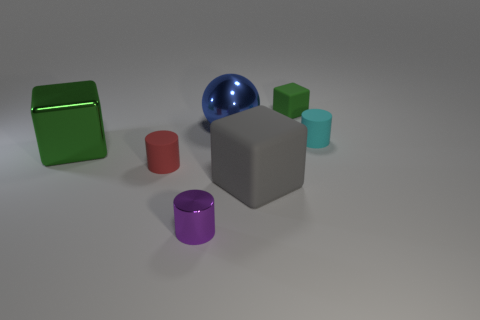Subtract all tiny matte cylinders. How many cylinders are left? 1 Subtract all cyan cylinders. How many cylinders are left? 2 Add 1 matte cubes. How many objects exist? 8 Subtract all cylinders. How many objects are left? 4 Subtract 3 blocks. How many blocks are left? 0 Subtract all gray balls. Subtract all cyan cubes. How many balls are left? 1 Subtract all yellow cylinders. How many red spheres are left? 0 Subtract all tiny purple cylinders. Subtract all tiny green rubber things. How many objects are left? 5 Add 5 large rubber blocks. How many large rubber blocks are left? 6 Add 4 tiny purple metal objects. How many tiny purple metal objects exist? 5 